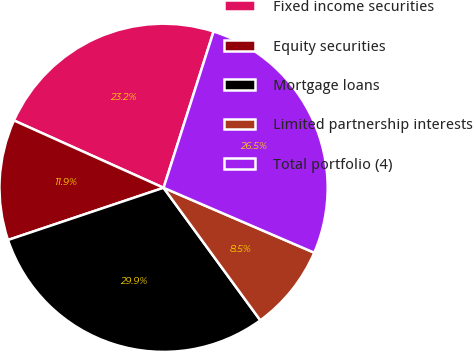Convert chart to OTSL. <chart><loc_0><loc_0><loc_500><loc_500><pie_chart><fcel>Fixed income securities<fcel>Equity securities<fcel>Mortgage loans<fcel>Limited partnership interests<fcel>Total portfolio (4)<nl><fcel>23.2%<fcel>11.88%<fcel>29.88%<fcel>8.49%<fcel>26.54%<nl></chart> 